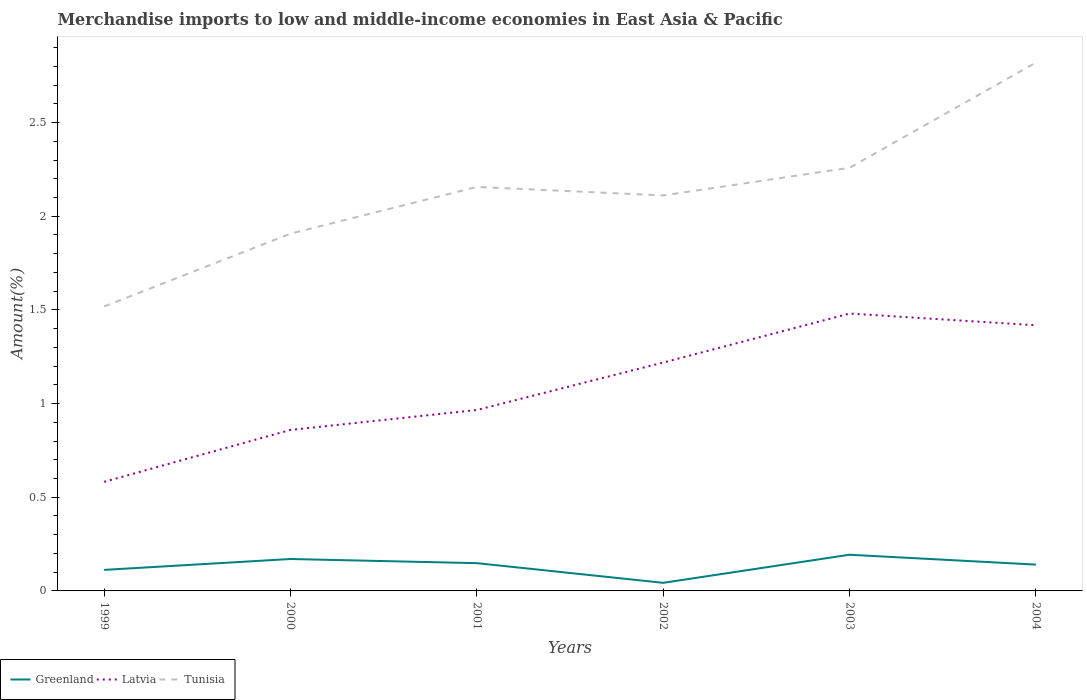Across all years, what is the maximum percentage of amount earned from merchandise imports in Latvia?
Make the answer very short. 0.58. In which year was the percentage of amount earned from merchandise imports in Tunisia maximum?
Make the answer very short. 1999. What is the total percentage of amount earned from merchandise imports in Greenland in the graph?
Your response must be concise. 0.07. What is the difference between the highest and the second highest percentage of amount earned from merchandise imports in Tunisia?
Offer a terse response. 1.3. What is the difference between the highest and the lowest percentage of amount earned from merchandise imports in Greenland?
Your response must be concise. 4. Is the percentage of amount earned from merchandise imports in Greenland strictly greater than the percentage of amount earned from merchandise imports in Tunisia over the years?
Your answer should be very brief. Yes. How many lines are there?
Provide a succinct answer. 3. What is the title of the graph?
Your answer should be very brief. Merchandise imports to low and middle-income economies in East Asia & Pacific. What is the label or title of the Y-axis?
Provide a short and direct response. Amount(%). What is the Amount(%) of Greenland in 1999?
Make the answer very short. 0.11. What is the Amount(%) of Latvia in 1999?
Your answer should be very brief. 0.58. What is the Amount(%) in Tunisia in 1999?
Give a very brief answer. 1.52. What is the Amount(%) in Greenland in 2000?
Provide a succinct answer. 0.17. What is the Amount(%) of Latvia in 2000?
Provide a succinct answer. 0.86. What is the Amount(%) of Tunisia in 2000?
Provide a short and direct response. 1.91. What is the Amount(%) in Greenland in 2001?
Your answer should be very brief. 0.15. What is the Amount(%) in Latvia in 2001?
Your response must be concise. 0.97. What is the Amount(%) in Tunisia in 2001?
Your answer should be compact. 2.16. What is the Amount(%) of Greenland in 2002?
Keep it short and to the point. 0.04. What is the Amount(%) in Latvia in 2002?
Offer a very short reply. 1.22. What is the Amount(%) in Tunisia in 2002?
Your answer should be very brief. 2.11. What is the Amount(%) in Greenland in 2003?
Offer a terse response. 0.19. What is the Amount(%) of Latvia in 2003?
Offer a terse response. 1.48. What is the Amount(%) of Tunisia in 2003?
Offer a terse response. 2.26. What is the Amount(%) of Greenland in 2004?
Make the answer very short. 0.14. What is the Amount(%) of Latvia in 2004?
Ensure brevity in your answer.  1.42. What is the Amount(%) in Tunisia in 2004?
Keep it short and to the point. 2.82. Across all years, what is the maximum Amount(%) in Greenland?
Provide a short and direct response. 0.19. Across all years, what is the maximum Amount(%) in Latvia?
Ensure brevity in your answer.  1.48. Across all years, what is the maximum Amount(%) in Tunisia?
Your answer should be compact. 2.82. Across all years, what is the minimum Amount(%) of Greenland?
Offer a terse response. 0.04. Across all years, what is the minimum Amount(%) of Latvia?
Give a very brief answer. 0.58. Across all years, what is the minimum Amount(%) of Tunisia?
Give a very brief answer. 1.52. What is the total Amount(%) of Greenland in the graph?
Your response must be concise. 0.81. What is the total Amount(%) in Latvia in the graph?
Provide a short and direct response. 6.52. What is the total Amount(%) in Tunisia in the graph?
Ensure brevity in your answer.  12.77. What is the difference between the Amount(%) in Greenland in 1999 and that in 2000?
Make the answer very short. -0.06. What is the difference between the Amount(%) in Latvia in 1999 and that in 2000?
Give a very brief answer. -0.28. What is the difference between the Amount(%) of Tunisia in 1999 and that in 2000?
Make the answer very short. -0.39. What is the difference between the Amount(%) of Greenland in 1999 and that in 2001?
Your response must be concise. -0.04. What is the difference between the Amount(%) of Latvia in 1999 and that in 2001?
Offer a terse response. -0.38. What is the difference between the Amount(%) of Tunisia in 1999 and that in 2001?
Provide a short and direct response. -0.64. What is the difference between the Amount(%) in Greenland in 1999 and that in 2002?
Ensure brevity in your answer.  0.07. What is the difference between the Amount(%) of Latvia in 1999 and that in 2002?
Your answer should be compact. -0.64. What is the difference between the Amount(%) in Tunisia in 1999 and that in 2002?
Your answer should be very brief. -0.59. What is the difference between the Amount(%) of Greenland in 1999 and that in 2003?
Give a very brief answer. -0.08. What is the difference between the Amount(%) in Latvia in 1999 and that in 2003?
Provide a succinct answer. -0.9. What is the difference between the Amount(%) of Tunisia in 1999 and that in 2003?
Ensure brevity in your answer.  -0.74. What is the difference between the Amount(%) of Greenland in 1999 and that in 2004?
Provide a short and direct response. -0.03. What is the difference between the Amount(%) of Latvia in 1999 and that in 2004?
Provide a short and direct response. -0.84. What is the difference between the Amount(%) in Tunisia in 1999 and that in 2004?
Keep it short and to the point. -1.3. What is the difference between the Amount(%) in Greenland in 2000 and that in 2001?
Make the answer very short. 0.02. What is the difference between the Amount(%) in Latvia in 2000 and that in 2001?
Offer a terse response. -0.11. What is the difference between the Amount(%) in Tunisia in 2000 and that in 2001?
Provide a short and direct response. -0.25. What is the difference between the Amount(%) in Greenland in 2000 and that in 2002?
Ensure brevity in your answer.  0.13. What is the difference between the Amount(%) of Latvia in 2000 and that in 2002?
Your answer should be very brief. -0.36. What is the difference between the Amount(%) in Tunisia in 2000 and that in 2002?
Keep it short and to the point. -0.2. What is the difference between the Amount(%) of Greenland in 2000 and that in 2003?
Offer a terse response. -0.02. What is the difference between the Amount(%) of Latvia in 2000 and that in 2003?
Keep it short and to the point. -0.62. What is the difference between the Amount(%) of Tunisia in 2000 and that in 2003?
Keep it short and to the point. -0.35. What is the difference between the Amount(%) of Greenland in 2000 and that in 2004?
Give a very brief answer. 0.03. What is the difference between the Amount(%) of Latvia in 2000 and that in 2004?
Keep it short and to the point. -0.56. What is the difference between the Amount(%) in Tunisia in 2000 and that in 2004?
Ensure brevity in your answer.  -0.91. What is the difference between the Amount(%) in Greenland in 2001 and that in 2002?
Offer a terse response. 0.1. What is the difference between the Amount(%) of Latvia in 2001 and that in 2002?
Provide a succinct answer. -0.25. What is the difference between the Amount(%) in Tunisia in 2001 and that in 2002?
Your response must be concise. 0.05. What is the difference between the Amount(%) in Greenland in 2001 and that in 2003?
Make the answer very short. -0.04. What is the difference between the Amount(%) in Latvia in 2001 and that in 2003?
Offer a terse response. -0.51. What is the difference between the Amount(%) in Tunisia in 2001 and that in 2003?
Make the answer very short. -0.1. What is the difference between the Amount(%) of Greenland in 2001 and that in 2004?
Make the answer very short. 0.01. What is the difference between the Amount(%) of Latvia in 2001 and that in 2004?
Ensure brevity in your answer.  -0.45. What is the difference between the Amount(%) in Tunisia in 2001 and that in 2004?
Provide a succinct answer. -0.66. What is the difference between the Amount(%) in Greenland in 2002 and that in 2003?
Provide a short and direct response. -0.15. What is the difference between the Amount(%) of Latvia in 2002 and that in 2003?
Your answer should be very brief. -0.26. What is the difference between the Amount(%) of Tunisia in 2002 and that in 2003?
Your answer should be compact. -0.15. What is the difference between the Amount(%) in Greenland in 2002 and that in 2004?
Ensure brevity in your answer.  -0.1. What is the difference between the Amount(%) in Latvia in 2002 and that in 2004?
Provide a succinct answer. -0.2. What is the difference between the Amount(%) of Tunisia in 2002 and that in 2004?
Make the answer very short. -0.71. What is the difference between the Amount(%) of Greenland in 2003 and that in 2004?
Make the answer very short. 0.05. What is the difference between the Amount(%) of Latvia in 2003 and that in 2004?
Offer a terse response. 0.06. What is the difference between the Amount(%) of Tunisia in 2003 and that in 2004?
Your answer should be compact. -0.56. What is the difference between the Amount(%) of Greenland in 1999 and the Amount(%) of Latvia in 2000?
Your response must be concise. -0.75. What is the difference between the Amount(%) in Greenland in 1999 and the Amount(%) in Tunisia in 2000?
Give a very brief answer. -1.79. What is the difference between the Amount(%) in Latvia in 1999 and the Amount(%) in Tunisia in 2000?
Offer a terse response. -1.32. What is the difference between the Amount(%) in Greenland in 1999 and the Amount(%) in Latvia in 2001?
Provide a succinct answer. -0.85. What is the difference between the Amount(%) of Greenland in 1999 and the Amount(%) of Tunisia in 2001?
Make the answer very short. -2.04. What is the difference between the Amount(%) of Latvia in 1999 and the Amount(%) of Tunisia in 2001?
Your response must be concise. -1.57. What is the difference between the Amount(%) of Greenland in 1999 and the Amount(%) of Latvia in 2002?
Make the answer very short. -1.11. What is the difference between the Amount(%) in Greenland in 1999 and the Amount(%) in Tunisia in 2002?
Offer a very short reply. -2. What is the difference between the Amount(%) in Latvia in 1999 and the Amount(%) in Tunisia in 2002?
Your answer should be very brief. -1.53. What is the difference between the Amount(%) of Greenland in 1999 and the Amount(%) of Latvia in 2003?
Ensure brevity in your answer.  -1.37. What is the difference between the Amount(%) of Greenland in 1999 and the Amount(%) of Tunisia in 2003?
Your response must be concise. -2.15. What is the difference between the Amount(%) in Latvia in 1999 and the Amount(%) in Tunisia in 2003?
Give a very brief answer. -1.68. What is the difference between the Amount(%) in Greenland in 1999 and the Amount(%) in Latvia in 2004?
Offer a very short reply. -1.31. What is the difference between the Amount(%) in Greenland in 1999 and the Amount(%) in Tunisia in 2004?
Provide a short and direct response. -2.71. What is the difference between the Amount(%) of Latvia in 1999 and the Amount(%) of Tunisia in 2004?
Offer a very short reply. -2.24. What is the difference between the Amount(%) of Greenland in 2000 and the Amount(%) of Latvia in 2001?
Provide a succinct answer. -0.8. What is the difference between the Amount(%) of Greenland in 2000 and the Amount(%) of Tunisia in 2001?
Offer a terse response. -1.99. What is the difference between the Amount(%) of Latvia in 2000 and the Amount(%) of Tunisia in 2001?
Offer a very short reply. -1.3. What is the difference between the Amount(%) in Greenland in 2000 and the Amount(%) in Latvia in 2002?
Provide a succinct answer. -1.05. What is the difference between the Amount(%) in Greenland in 2000 and the Amount(%) in Tunisia in 2002?
Ensure brevity in your answer.  -1.94. What is the difference between the Amount(%) of Latvia in 2000 and the Amount(%) of Tunisia in 2002?
Provide a short and direct response. -1.25. What is the difference between the Amount(%) of Greenland in 2000 and the Amount(%) of Latvia in 2003?
Your answer should be very brief. -1.31. What is the difference between the Amount(%) in Greenland in 2000 and the Amount(%) in Tunisia in 2003?
Provide a succinct answer. -2.09. What is the difference between the Amount(%) of Latvia in 2000 and the Amount(%) of Tunisia in 2003?
Your response must be concise. -1.4. What is the difference between the Amount(%) in Greenland in 2000 and the Amount(%) in Latvia in 2004?
Offer a very short reply. -1.25. What is the difference between the Amount(%) of Greenland in 2000 and the Amount(%) of Tunisia in 2004?
Ensure brevity in your answer.  -2.65. What is the difference between the Amount(%) in Latvia in 2000 and the Amount(%) in Tunisia in 2004?
Offer a terse response. -1.96. What is the difference between the Amount(%) in Greenland in 2001 and the Amount(%) in Latvia in 2002?
Offer a very short reply. -1.07. What is the difference between the Amount(%) in Greenland in 2001 and the Amount(%) in Tunisia in 2002?
Your answer should be very brief. -1.96. What is the difference between the Amount(%) of Latvia in 2001 and the Amount(%) of Tunisia in 2002?
Provide a short and direct response. -1.15. What is the difference between the Amount(%) of Greenland in 2001 and the Amount(%) of Latvia in 2003?
Keep it short and to the point. -1.33. What is the difference between the Amount(%) of Greenland in 2001 and the Amount(%) of Tunisia in 2003?
Your answer should be compact. -2.11. What is the difference between the Amount(%) of Latvia in 2001 and the Amount(%) of Tunisia in 2003?
Give a very brief answer. -1.29. What is the difference between the Amount(%) of Greenland in 2001 and the Amount(%) of Latvia in 2004?
Ensure brevity in your answer.  -1.27. What is the difference between the Amount(%) in Greenland in 2001 and the Amount(%) in Tunisia in 2004?
Provide a short and direct response. -2.67. What is the difference between the Amount(%) in Latvia in 2001 and the Amount(%) in Tunisia in 2004?
Ensure brevity in your answer.  -1.85. What is the difference between the Amount(%) in Greenland in 2002 and the Amount(%) in Latvia in 2003?
Offer a terse response. -1.44. What is the difference between the Amount(%) in Greenland in 2002 and the Amount(%) in Tunisia in 2003?
Your response must be concise. -2.22. What is the difference between the Amount(%) of Latvia in 2002 and the Amount(%) of Tunisia in 2003?
Your response must be concise. -1.04. What is the difference between the Amount(%) of Greenland in 2002 and the Amount(%) of Latvia in 2004?
Make the answer very short. -1.37. What is the difference between the Amount(%) in Greenland in 2002 and the Amount(%) in Tunisia in 2004?
Your response must be concise. -2.78. What is the difference between the Amount(%) of Latvia in 2002 and the Amount(%) of Tunisia in 2004?
Provide a succinct answer. -1.6. What is the difference between the Amount(%) of Greenland in 2003 and the Amount(%) of Latvia in 2004?
Keep it short and to the point. -1.22. What is the difference between the Amount(%) in Greenland in 2003 and the Amount(%) in Tunisia in 2004?
Give a very brief answer. -2.63. What is the difference between the Amount(%) in Latvia in 2003 and the Amount(%) in Tunisia in 2004?
Offer a terse response. -1.34. What is the average Amount(%) of Greenland per year?
Your response must be concise. 0.13. What is the average Amount(%) in Latvia per year?
Give a very brief answer. 1.09. What is the average Amount(%) in Tunisia per year?
Keep it short and to the point. 2.13. In the year 1999, what is the difference between the Amount(%) of Greenland and Amount(%) of Latvia?
Your answer should be very brief. -0.47. In the year 1999, what is the difference between the Amount(%) in Greenland and Amount(%) in Tunisia?
Keep it short and to the point. -1.41. In the year 1999, what is the difference between the Amount(%) of Latvia and Amount(%) of Tunisia?
Your response must be concise. -0.94. In the year 2000, what is the difference between the Amount(%) of Greenland and Amount(%) of Latvia?
Keep it short and to the point. -0.69. In the year 2000, what is the difference between the Amount(%) of Greenland and Amount(%) of Tunisia?
Offer a terse response. -1.74. In the year 2000, what is the difference between the Amount(%) of Latvia and Amount(%) of Tunisia?
Make the answer very short. -1.05. In the year 2001, what is the difference between the Amount(%) in Greenland and Amount(%) in Latvia?
Make the answer very short. -0.82. In the year 2001, what is the difference between the Amount(%) of Greenland and Amount(%) of Tunisia?
Keep it short and to the point. -2.01. In the year 2001, what is the difference between the Amount(%) of Latvia and Amount(%) of Tunisia?
Your answer should be very brief. -1.19. In the year 2002, what is the difference between the Amount(%) of Greenland and Amount(%) of Latvia?
Provide a succinct answer. -1.18. In the year 2002, what is the difference between the Amount(%) in Greenland and Amount(%) in Tunisia?
Provide a short and direct response. -2.07. In the year 2002, what is the difference between the Amount(%) of Latvia and Amount(%) of Tunisia?
Your response must be concise. -0.89. In the year 2003, what is the difference between the Amount(%) in Greenland and Amount(%) in Latvia?
Give a very brief answer. -1.29. In the year 2003, what is the difference between the Amount(%) in Greenland and Amount(%) in Tunisia?
Offer a very short reply. -2.07. In the year 2003, what is the difference between the Amount(%) of Latvia and Amount(%) of Tunisia?
Your response must be concise. -0.78. In the year 2004, what is the difference between the Amount(%) of Greenland and Amount(%) of Latvia?
Your response must be concise. -1.28. In the year 2004, what is the difference between the Amount(%) in Greenland and Amount(%) in Tunisia?
Provide a succinct answer. -2.68. In the year 2004, what is the difference between the Amount(%) in Latvia and Amount(%) in Tunisia?
Ensure brevity in your answer.  -1.4. What is the ratio of the Amount(%) of Greenland in 1999 to that in 2000?
Make the answer very short. 0.66. What is the ratio of the Amount(%) in Latvia in 1999 to that in 2000?
Provide a short and direct response. 0.68. What is the ratio of the Amount(%) of Tunisia in 1999 to that in 2000?
Keep it short and to the point. 0.8. What is the ratio of the Amount(%) in Greenland in 1999 to that in 2001?
Your response must be concise. 0.76. What is the ratio of the Amount(%) in Latvia in 1999 to that in 2001?
Provide a succinct answer. 0.6. What is the ratio of the Amount(%) of Tunisia in 1999 to that in 2001?
Offer a very short reply. 0.7. What is the ratio of the Amount(%) of Greenland in 1999 to that in 2002?
Provide a succinct answer. 2.6. What is the ratio of the Amount(%) of Latvia in 1999 to that in 2002?
Offer a very short reply. 0.48. What is the ratio of the Amount(%) of Tunisia in 1999 to that in 2002?
Ensure brevity in your answer.  0.72. What is the ratio of the Amount(%) in Greenland in 1999 to that in 2003?
Offer a very short reply. 0.58. What is the ratio of the Amount(%) in Latvia in 1999 to that in 2003?
Provide a succinct answer. 0.39. What is the ratio of the Amount(%) in Tunisia in 1999 to that in 2003?
Ensure brevity in your answer.  0.67. What is the ratio of the Amount(%) in Greenland in 1999 to that in 2004?
Provide a succinct answer. 0.8. What is the ratio of the Amount(%) of Latvia in 1999 to that in 2004?
Your answer should be very brief. 0.41. What is the ratio of the Amount(%) in Tunisia in 1999 to that in 2004?
Offer a very short reply. 0.54. What is the ratio of the Amount(%) in Greenland in 2000 to that in 2001?
Provide a short and direct response. 1.15. What is the ratio of the Amount(%) in Latvia in 2000 to that in 2001?
Provide a succinct answer. 0.89. What is the ratio of the Amount(%) in Tunisia in 2000 to that in 2001?
Ensure brevity in your answer.  0.88. What is the ratio of the Amount(%) in Greenland in 2000 to that in 2002?
Ensure brevity in your answer.  3.94. What is the ratio of the Amount(%) in Latvia in 2000 to that in 2002?
Make the answer very short. 0.7. What is the ratio of the Amount(%) in Tunisia in 2000 to that in 2002?
Give a very brief answer. 0.9. What is the ratio of the Amount(%) of Greenland in 2000 to that in 2003?
Provide a succinct answer. 0.88. What is the ratio of the Amount(%) of Latvia in 2000 to that in 2003?
Keep it short and to the point. 0.58. What is the ratio of the Amount(%) of Tunisia in 2000 to that in 2003?
Offer a very short reply. 0.84. What is the ratio of the Amount(%) in Greenland in 2000 to that in 2004?
Your answer should be very brief. 1.21. What is the ratio of the Amount(%) in Latvia in 2000 to that in 2004?
Provide a succinct answer. 0.61. What is the ratio of the Amount(%) in Tunisia in 2000 to that in 2004?
Provide a succinct answer. 0.68. What is the ratio of the Amount(%) of Greenland in 2001 to that in 2002?
Provide a short and direct response. 3.43. What is the ratio of the Amount(%) of Latvia in 2001 to that in 2002?
Your answer should be very brief. 0.79. What is the ratio of the Amount(%) of Tunisia in 2001 to that in 2002?
Offer a terse response. 1.02. What is the ratio of the Amount(%) of Greenland in 2001 to that in 2003?
Give a very brief answer. 0.77. What is the ratio of the Amount(%) in Latvia in 2001 to that in 2003?
Ensure brevity in your answer.  0.65. What is the ratio of the Amount(%) of Tunisia in 2001 to that in 2003?
Your answer should be very brief. 0.95. What is the ratio of the Amount(%) in Greenland in 2001 to that in 2004?
Ensure brevity in your answer.  1.06. What is the ratio of the Amount(%) of Latvia in 2001 to that in 2004?
Your answer should be very brief. 0.68. What is the ratio of the Amount(%) of Tunisia in 2001 to that in 2004?
Your answer should be compact. 0.76. What is the ratio of the Amount(%) of Greenland in 2002 to that in 2003?
Ensure brevity in your answer.  0.22. What is the ratio of the Amount(%) of Latvia in 2002 to that in 2003?
Provide a succinct answer. 0.82. What is the ratio of the Amount(%) in Tunisia in 2002 to that in 2003?
Your answer should be very brief. 0.93. What is the ratio of the Amount(%) in Greenland in 2002 to that in 2004?
Keep it short and to the point. 0.31. What is the ratio of the Amount(%) of Latvia in 2002 to that in 2004?
Give a very brief answer. 0.86. What is the ratio of the Amount(%) in Tunisia in 2002 to that in 2004?
Give a very brief answer. 0.75. What is the ratio of the Amount(%) in Greenland in 2003 to that in 2004?
Keep it short and to the point. 1.38. What is the ratio of the Amount(%) of Latvia in 2003 to that in 2004?
Your response must be concise. 1.04. What is the ratio of the Amount(%) of Tunisia in 2003 to that in 2004?
Your response must be concise. 0.8. What is the difference between the highest and the second highest Amount(%) of Greenland?
Offer a very short reply. 0.02. What is the difference between the highest and the second highest Amount(%) in Latvia?
Offer a terse response. 0.06. What is the difference between the highest and the second highest Amount(%) of Tunisia?
Provide a succinct answer. 0.56. What is the difference between the highest and the lowest Amount(%) of Greenland?
Your answer should be very brief. 0.15. What is the difference between the highest and the lowest Amount(%) of Latvia?
Offer a very short reply. 0.9. What is the difference between the highest and the lowest Amount(%) of Tunisia?
Provide a short and direct response. 1.3. 